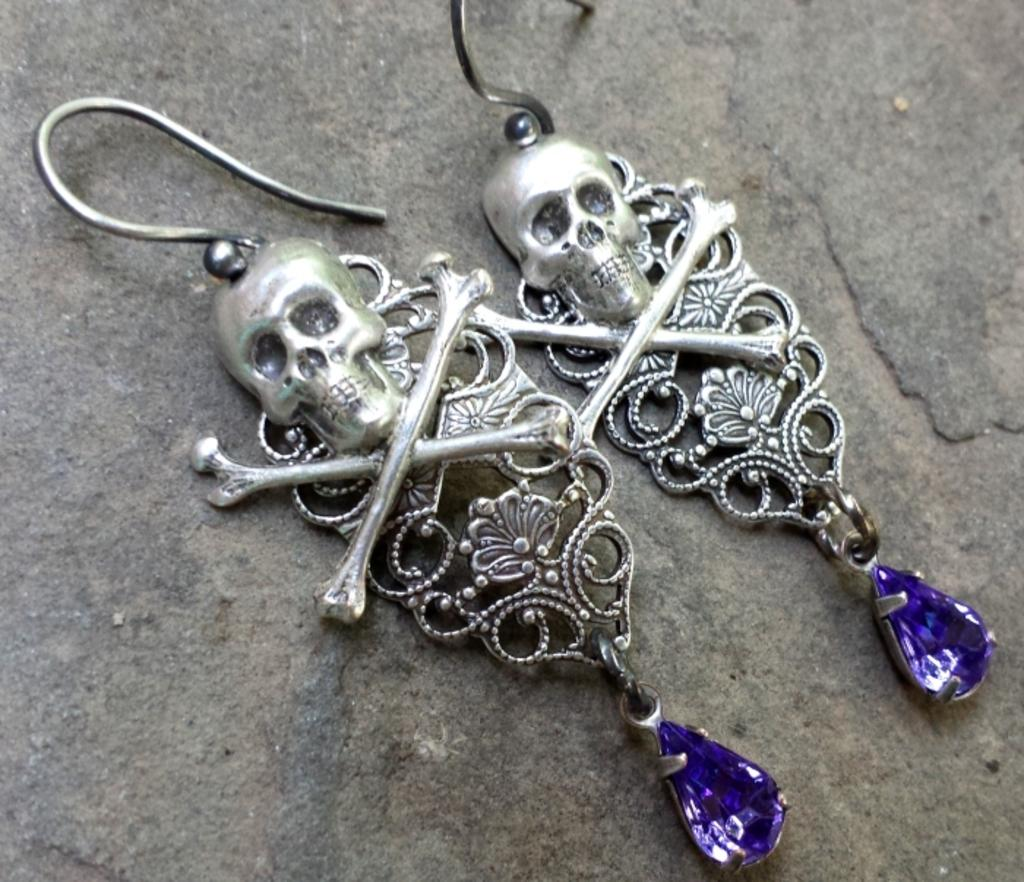What is on the floor in the image? There are earrings on the floor in the image. What type of crayon can be seen on the floor in the image? There is no crayon present on the floor in the image; it only features earrings. 